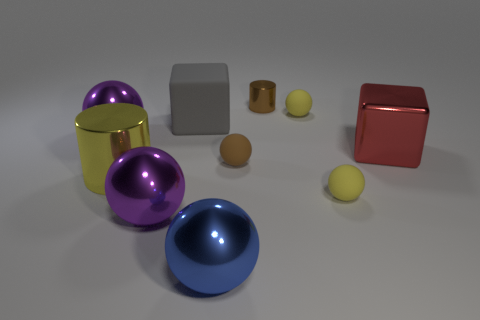Subtract all yellow balls. How many balls are left? 4 Subtract all gray cubes. How many cubes are left? 1 Subtract 1 cylinders. How many cylinders are left? 1 Subtract all balls. How many objects are left? 4 Subtract all purple cubes. How many red spheres are left? 0 Subtract 0 red balls. How many objects are left? 10 Subtract all red balls. Subtract all gray cylinders. How many balls are left? 6 Subtract all large yellow metal cylinders. Subtract all large spheres. How many objects are left? 6 Add 3 large metal spheres. How many large metal spheres are left? 6 Add 7 large cylinders. How many large cylinders exist? 8 